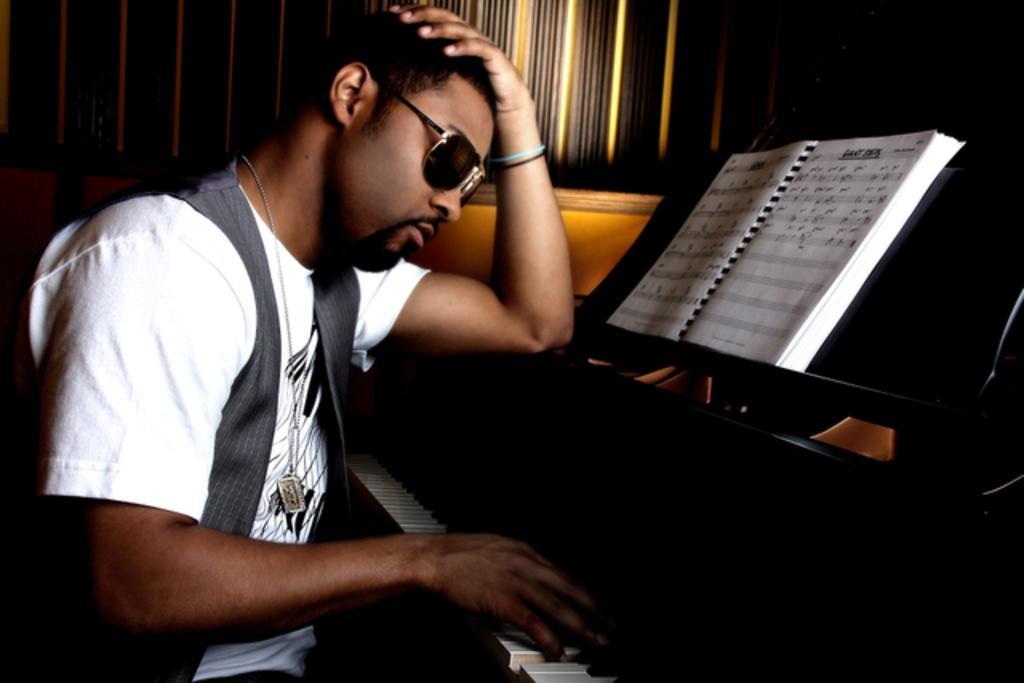Could you give a brief overview of what you see in this image? In this picture we can see a man who is playing piano. He has spectacles and this is the book. 